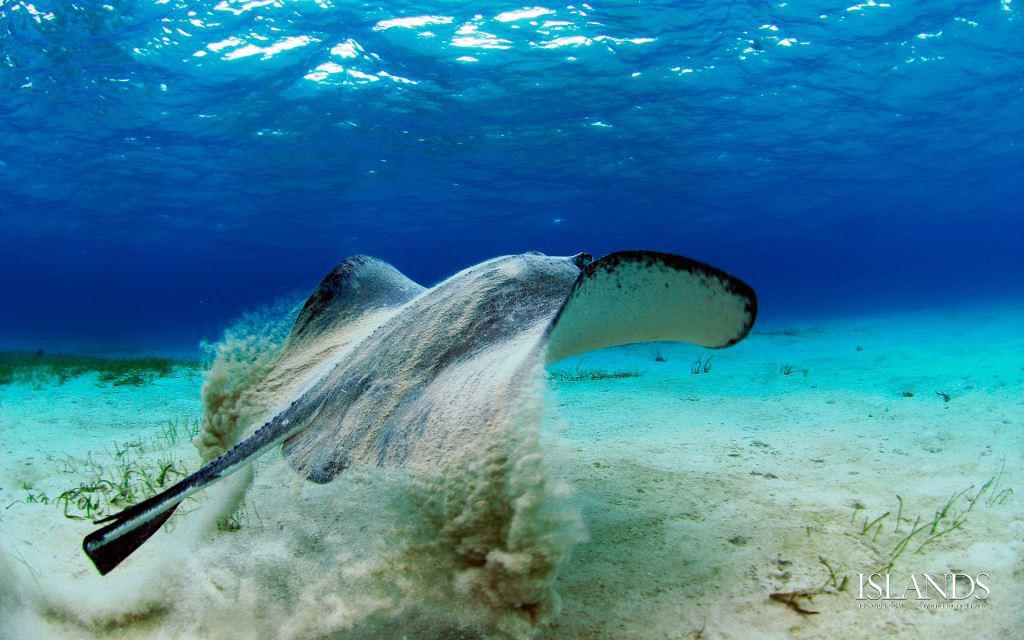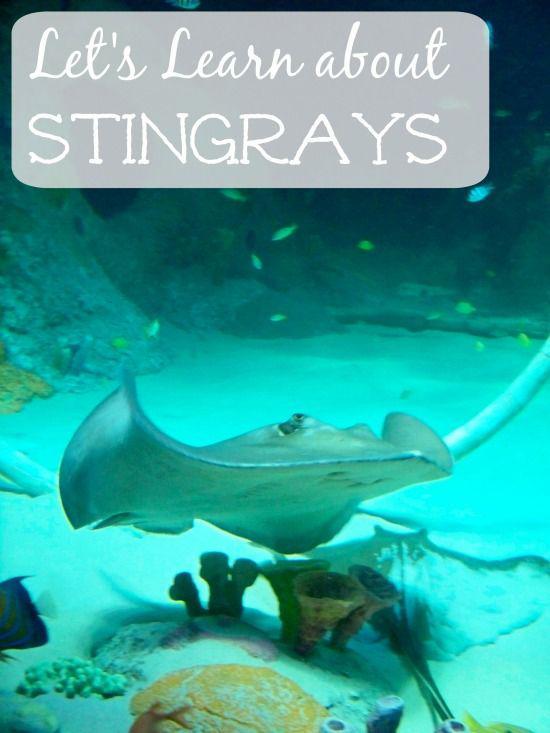The first image is the image on the left, the second image is the image on the right. Evaluate the accuracy of this statement regarding the images: "At least three sting rays are swimming in the water.". Is it true? Answer yes or no. No. The first image is the image on the left, the second image is the image on the right. For the images displayed, is the sentence "Each images shows just one stingray in the foreground." factually correct? Answer yes or no. Yes. 